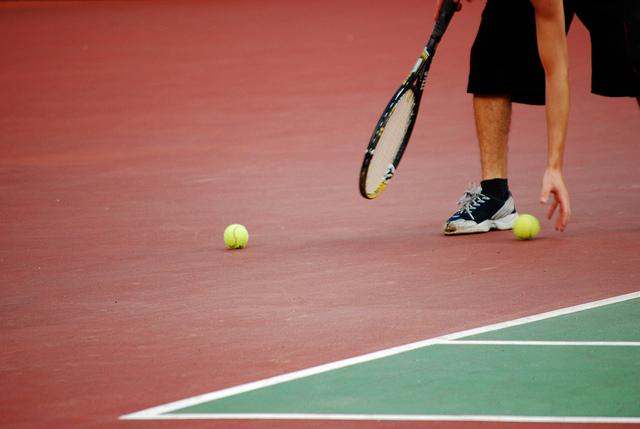How many balls are here?
Be succinct. 2. What sex is the tennis player likely to be?
Short answer required. Male. Is the man trying to grab the tennis ball?
Give a very brief answer. Yes. 